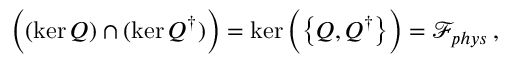<formula> <loc_0><loc_0><loc_500><loc_500>\left ( ( \ker Q ) \cap ( \ker Q ^ { \dagger } ) \right ) = \ker \left ( \left \{ Q , Q ^ { \dagger } \right \} \right ) = \mathcal { F } _ { p h y s } \, ,</formula> 